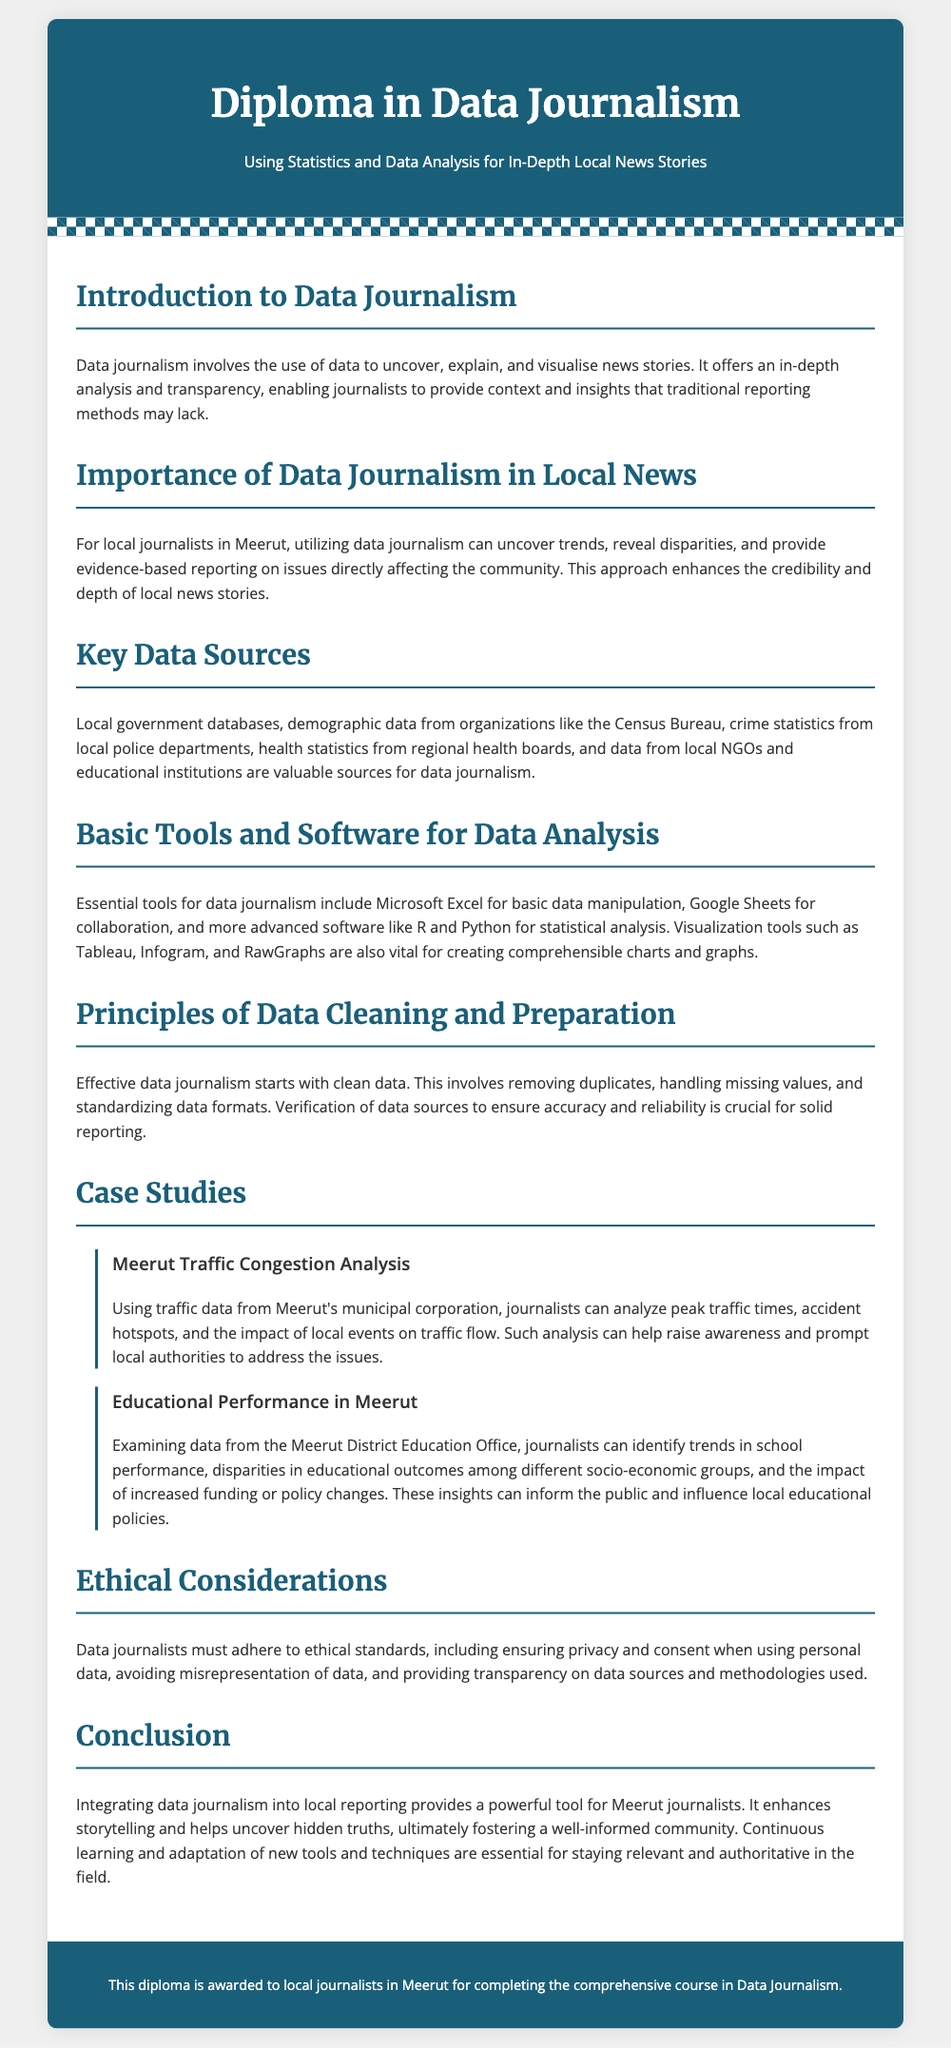What is the title of the diploma? The title of the diploma is stated in the header section of the document as "Diploma in Data Journalism".
Answer: Diploma in Data Journalism What does data journalism involve? Data journalism involves using data to uncover, explain, and visualize news stories, as mentioned in the introduction.
Answer: Using data to uncover, explain, and visualize news stories Which local organization provides demographic data? The document states that demographic data can be sourced from organizations like the Census Bureau.
Answer: Census Bureau What is one essential tool mentioned for data analysis? The document lists Microsoft Excel as an essential tool for basic data manipulation under the tools section.
Answer: Microsoft Excel What ethical consideration is highlighted in the document? The document emphasizes ensuring privacy and consent when using personal data as part of ethical standards.
Answer: Privacy and consent Which case study focuses on traffic in Meerut? The section includes a case study on "Meerut Traffic Congestion Analysis".
Answer: Meerut Traffic Congestion Analysis What is the purpose of data cleaning and preparation? The document notes that effective data journalism starts with clean data to ensure accuracy and reliability.
Answer: Ensure accuracy and reliability How does data journalism enhance local news stories? It provides evidence-based reporting and uncovers trends, enhancing the credibility of local stories.
Answer: Provides evidence-based reporting and uncovers trends What do journalists need to do to stay relevant in data journalism? The conclusion states that continuous learning and adaptation of new tools and techniques are essential for staying relevant.
Answer: Continuous learning and adaptation of new tools and techniques 